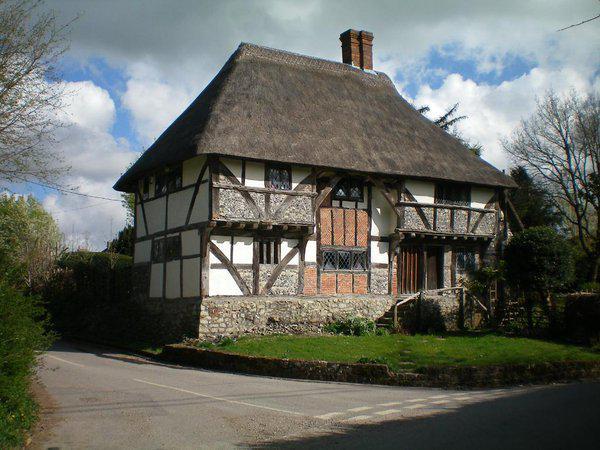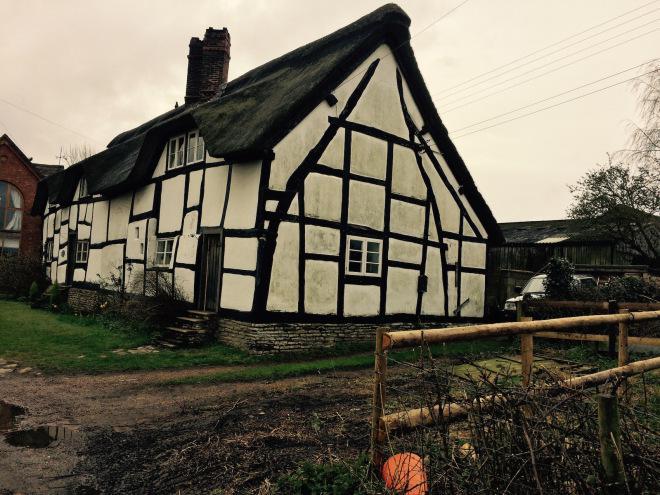The first image is the image on the left, the second image is the image on the right. Given the left and right images, does the statement "There is a fence bordering the house in one of the images." hold true? Answer yes or no. Yes. The first image is the image on the left, the second image is the image on the right. Evaluate the accuracy of this statement regarding the images: "The left image shows the front of a white house with bold dark lines on it forming geometric patterns, a chimney on the left end, and a thick gray peaked roof with at least one notched cut-out for windows.". Is it true? Answer yes or no. No. 